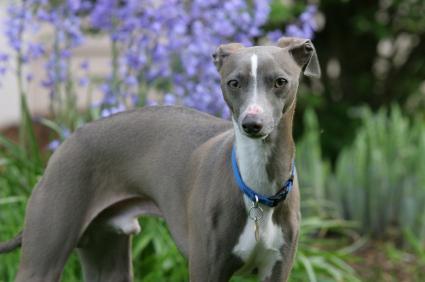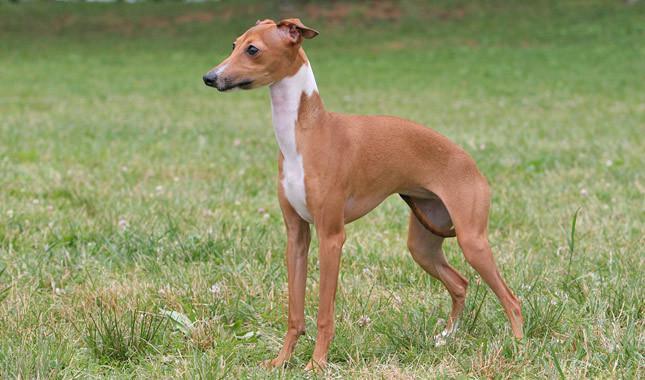The first image is the image on the left, the second image is the image on the right. Considering the images on both sides, is "There is a plant behind at least one of the dogs." valid? Answer yes or no. Yes. The first image is the image on the left, the second image is the image on the right. Examine the images to the left and right. Is the description "The right image shows a dog with all four paws on green grass." accurate? Answer yes or no. Yes. The first image is the image on the left, the second image is the image on the right. Evaluate the accuracy of this statement regarding the images: "the dog in the image on the right has its tail tucked between its legs". Is it true? Answer yes or no. Yes. 